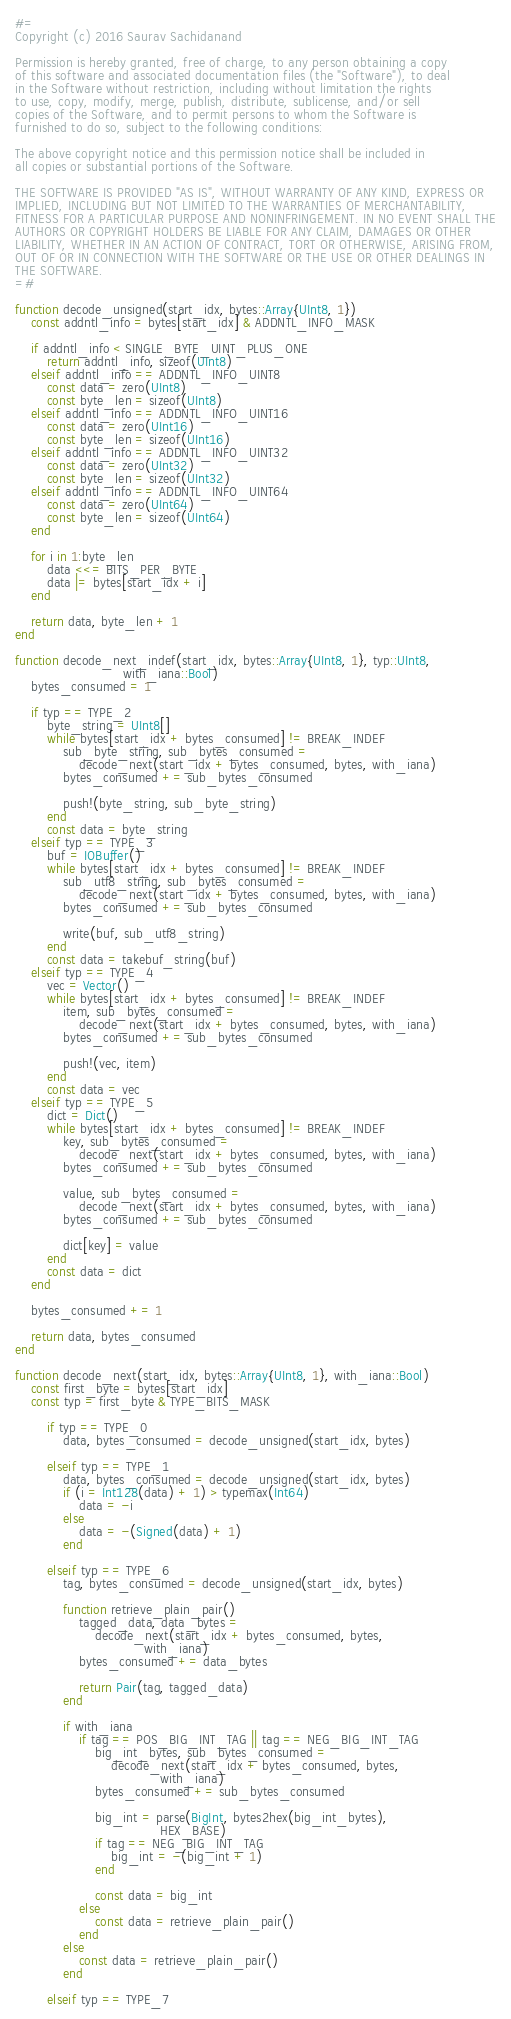<code> <loc_0><loc_0><loc_500><loc_500><_Julia_>#=
Copyright (c) 2016 Saurav Sachidanand

Permission is hereby granted, free of charge, to any person obtaining a copy
of this software and associated documentation files (the "Software"), to deal
in the Software without restriction, including without limitation the rights
to use, copy, modify, merge, publish, distribute, sublicense, and/or sell
copies of the Software, and to permit persons to whom the Software is
furnished to do so, subject to the following conditions:

The above copyright notice and this permission notice shall be included in
all copies or substantial portions of the Software.

THE SOFTWARE IS PROVIDED "AS IS", WITHOUT WARRANTY OF ANY KIND, EXPRESS OR
IMPLIED, INCLUDING BUT NOT LIMITED TO THE WARRANTIES OF MERCHANTABILITY,
FITNESS FOR A PARTICULAR PURPOSE AND NONINFRINGEMENT. IN NO EVENT SHALL THE
AUTHORS OR COPYRIGHT HOLDERS BE LIABLE FOR ANY CLAIM, DAMAGES OR OTHER
LIABILITY, WHETHER IN AN ACTION OF CONTRACT, TORT OR OTHERWISE, ARISING FROM,
OUT OF OR IN CONNECTION WITH THE SOFTWARE OR THE USE OR OTHER DEALINGS IN
THE SOFTWARE.
=#

function decode_unsigned(start_idx, bytes::Array{UInt8, 1})
    const addntl_info = bytes[start_idx] & ADDNTL_INFO_MASK

    if addntl_info < SINGLE_BYTE_UINT_PLUS_ONE
        return addntl_info, sizeof(UInt8)
    elseif addntl_info == ADDNTL_INFO_UINT8
        const data = zero(UInt8)
        const byte_len = sizeof(UInt8)
    elseif addntl_info == ADDNTL_INFO_UINT16
        const data = zero(UInt16)
        const byte_len = sizeof(UInt16)
    elseif addntl_info == ADDNTL_INFO_UINT32
        const data = zero(UInt32)
        const byte_len = sizeof(UInt32)
    elseif addntl_info == ADDNTL_INFO_UINT64
        const data = zero(UInt64)
        const byte_len = sizeof(UInt64)
    end

    for i in 1:byte_len
        data <<= BITS_PER_BYTE
        data |= bytes[start_idx + i]
    end

    return data, byte_len + 1
end

function decode_next_indef(start_idx, bytes::Array{UInt8, 1}, typ::UInt8,
                           with_iana::Bool)
    bytes_consumed = 1

    if typ == TYPE_2
        byte_string = UInt8[]
        while bytes[start_idx + bytes_consumed] != BREAK_INDEF
            sub_byte_string, sub_bytes_consumed =
                decode_next(start_idx + bytes_consumed, bytes, with_iana)
            bytes_consumed += sub_bytes_consumed

            push!(byte_string, sub_byte_string)
        end
        const data = byte_string
    elseif typ == TYPE_3
        buf = IOBuffer()
        while bytes[start_idx + bytes_consumed] != BREAK_INDEF
            sub_utf8_string, sub_bytes_consumed =
                decode_next(start_idx + bytes_consumed, bytes, with_iana)
            bytes_consumed += sub_bytes_consumed

            write(buf, sub_utf8_string)
        end
        const data = takebuf_string(buf)
    elseif typ == TYPE_4
        vec = Vector()
        while bytes[start_idx + bytes_consumed] != BREAK_INDEF
            item, sub_bytes_consumed =
                decode_next(start_idx + bytes_consumed, bytes, with_iana)
            bytes_consumed += sub_bytes_consumed

            push!(vec, item)
        end
        const data = vec
    elseif typ == TYPE_5
        dict = Dict()
        while bytes[start_idx + bytes_consumed] != BREAK_INDEF
            key, sub_bytes_consumed =
                decode_next(start_idx + bytes_consumed, bytes, with_iana)
            bytes_consumed += sub_bytes_consumed

            value, sub_bytes_consumed =
                decode_next(start_idx + bytes_consumed, bytes, with_iana)
            bytes_consumed += sub_bytes_consumed

            dict[key] = value
        end
        const data = dict
    end

    bytes_consumed += 1

    return data, bytes_consumed
end

function decode_next(start_idx, bytes::Array{UInt8, 1}, with_iana::Bool)
    const first_byte = bytes[start_idx]
    const typ = first_byte & TYPE_BITS_MASK

        if typ == TYPE_0
            data, bytes_consumed = decode_unsigned(start_idx, bytes)

        elseif typ == TYPE_1
            data, bytes_consumed = decode_unsigned(start_idx, bytes)
            if (i = Int128(data) + 1) > typemax(Int64)
                data = -i
            else
                data = -(Signed(data) + 1)
            end

        elseif typ == TYPE_6
            tag, bytes_consumed = decode_unsigned(start_idx, bytes)

            function retrieve_plain_pair()
                tagged_data, data_bytes =
                    decode_next(start_idx + bytes_consumed, bytes,
                                with_iana)
                bytes_consumed += data_bytes

                return Pair(tag, tagged_data)
            end

            if with_iana
                if tag == POS_BIG_INT_TAG || tag == NEG_BIG_INT_TAG
                    big_int_bytes, sub_bytes_consumed =
                        decode_next(start_idx + bytes_consumed, bytes,
                                    with_iana)
                    bytes_consumed += sub_bytes_consumed

                    big_int = parse(BigInt, bytes2hex(big_int_bytes),
                                    HEX_BASE)
                    if tag == NEG_BIG_INT_TAG
                        big_int = -(big_int + 1)
                    end

                    const data = big_int
                else
                    const data = retrieve_plain_pair()
                end
            else
                const data = retrieve_plain_pair()
            end

        elseif typ == TYPE_7</code> 